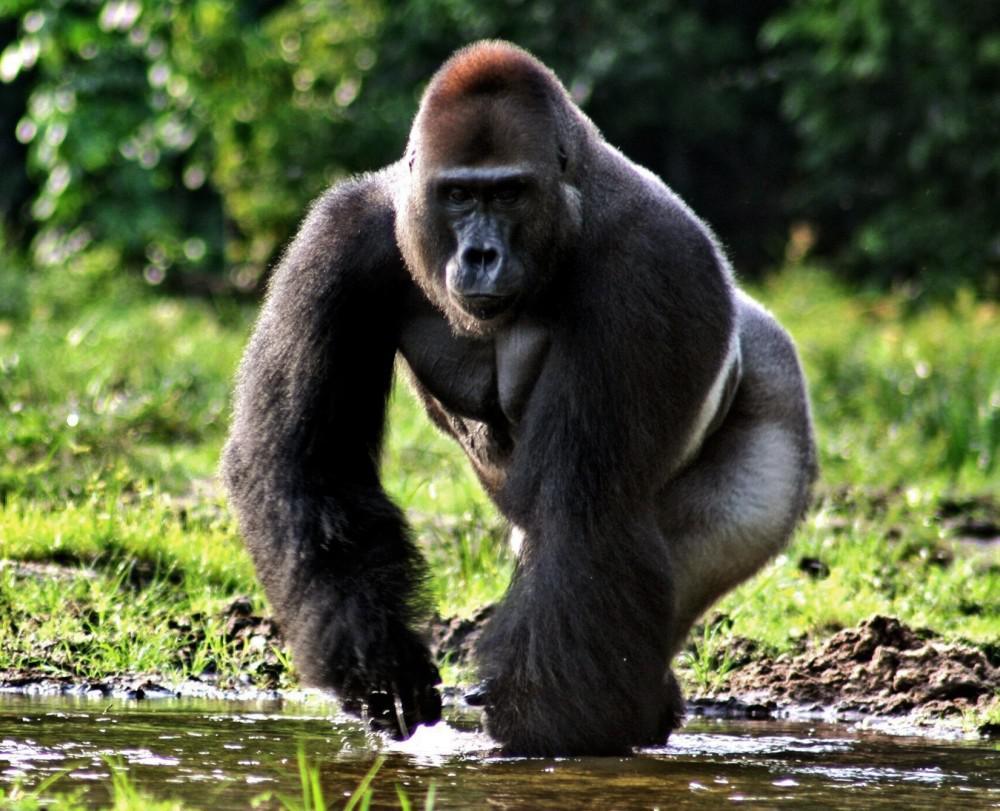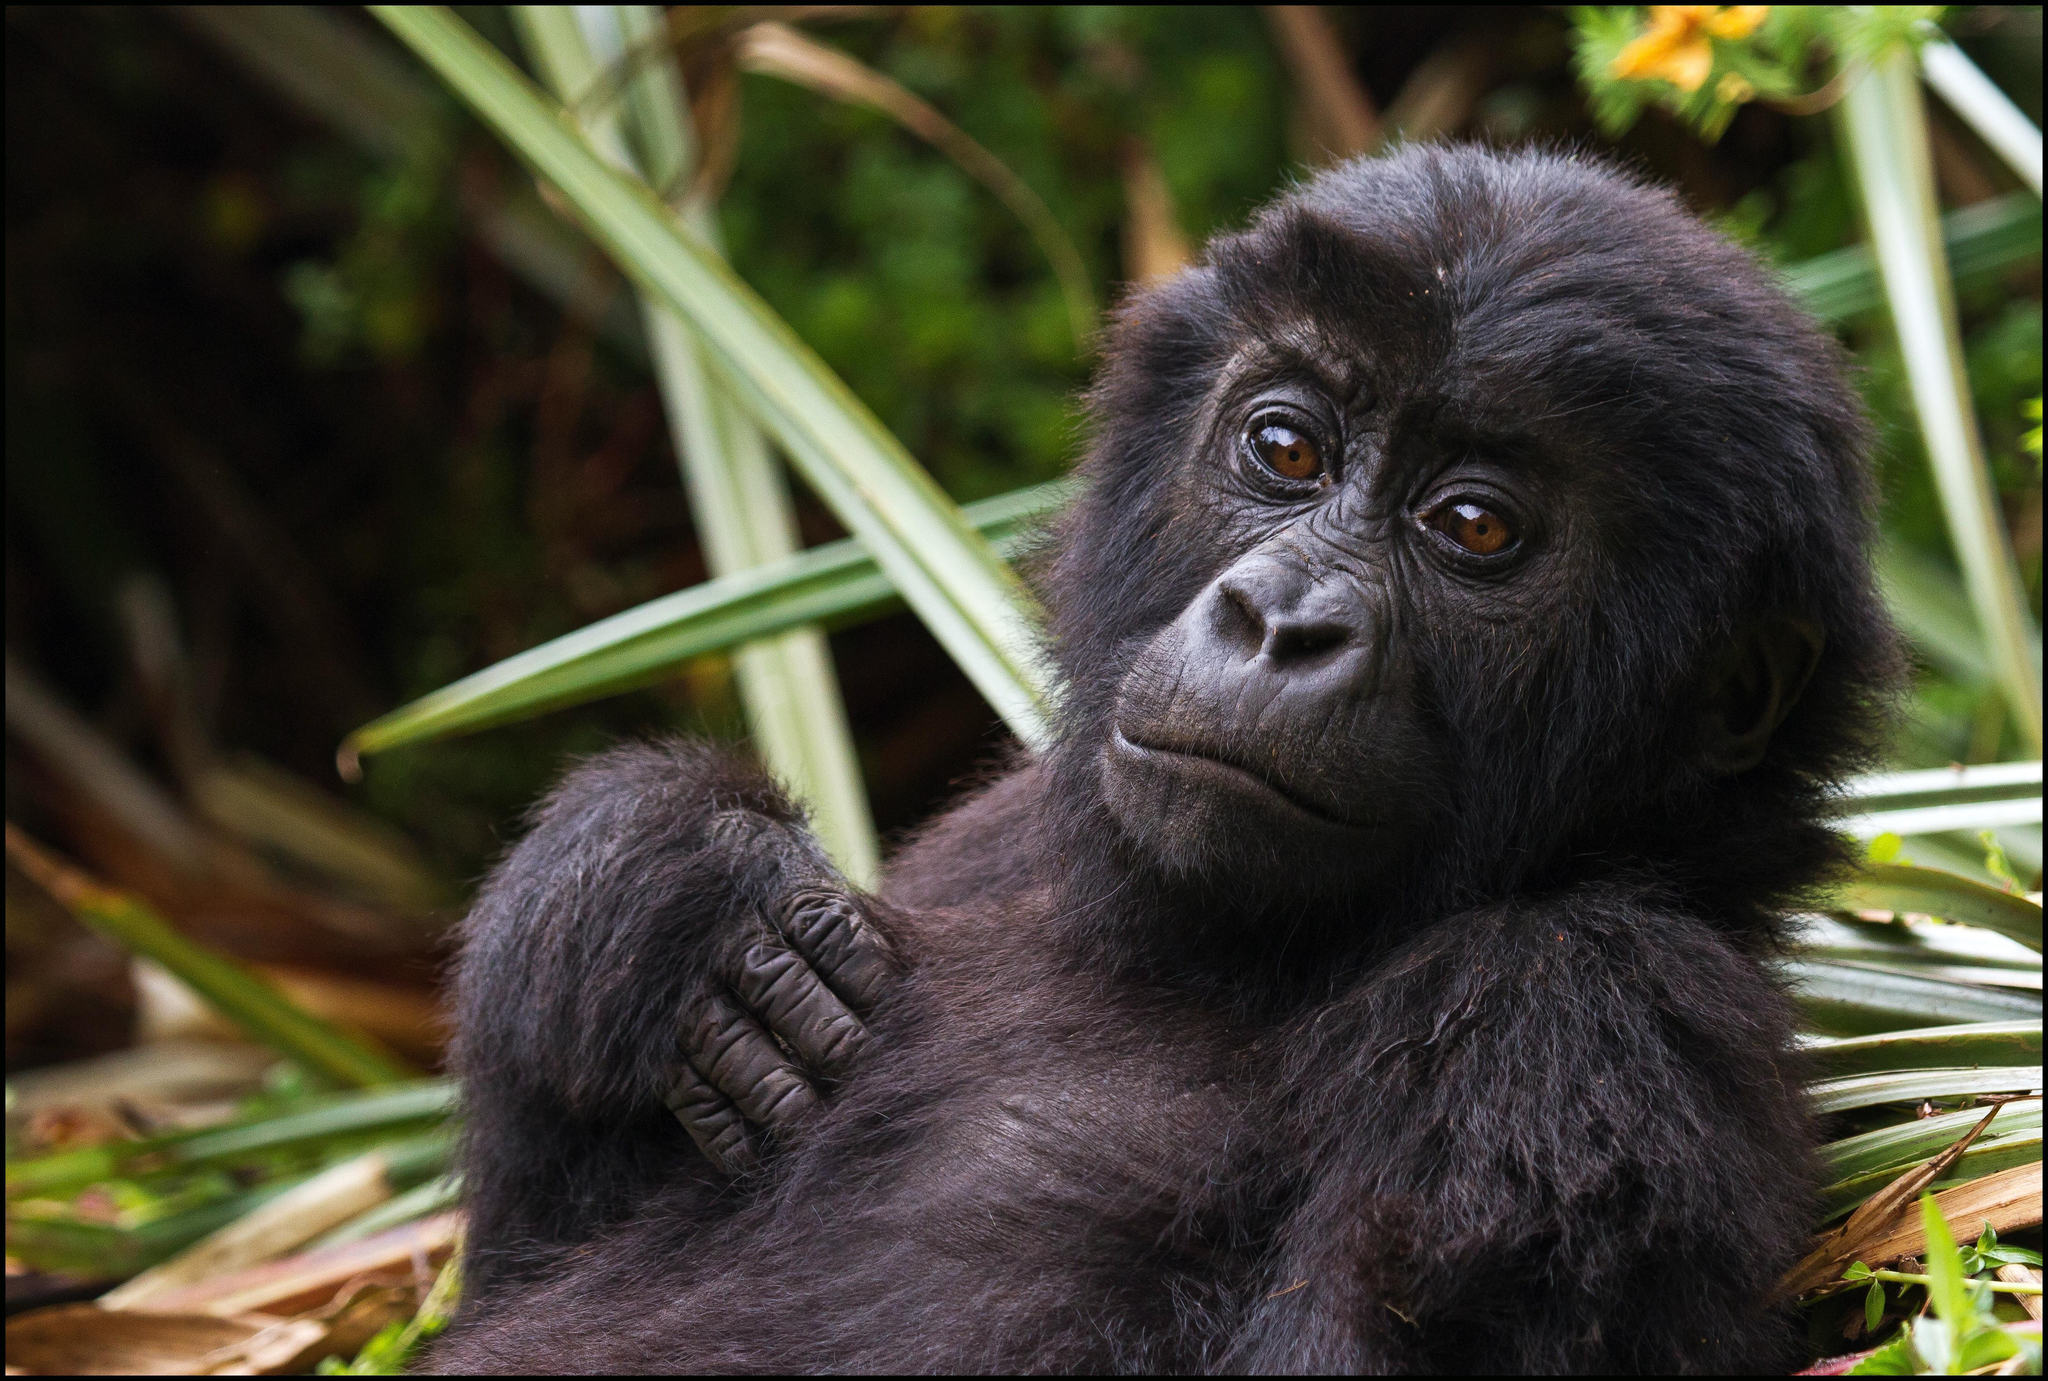The first image is the image on the left, the second image is the image on the right. Considering the images on both sides, is "A gorilla is eating something in one of the images." valid? Answer yes or no. No. The first image is the image on the left, the second image is the image on the right. Given the left and right images, does the statement "An image shows one gorilla munching on something." hold true? Answer yes or no. No. 